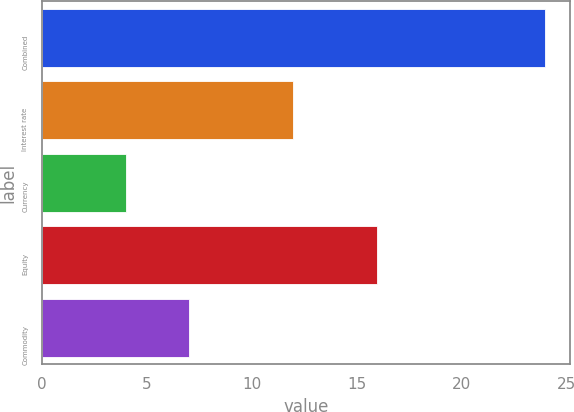<chart> <loc_0><loc_0><loc_500><loc_500><bar_chart><fcel>Combined<fcel>Interest rate<fcel>Currency<fcel>Equity<fcel>Commodity<nl><fcel>24<fcel>12<fcel>4<fcel>16<fcel>7<nl></chart> 